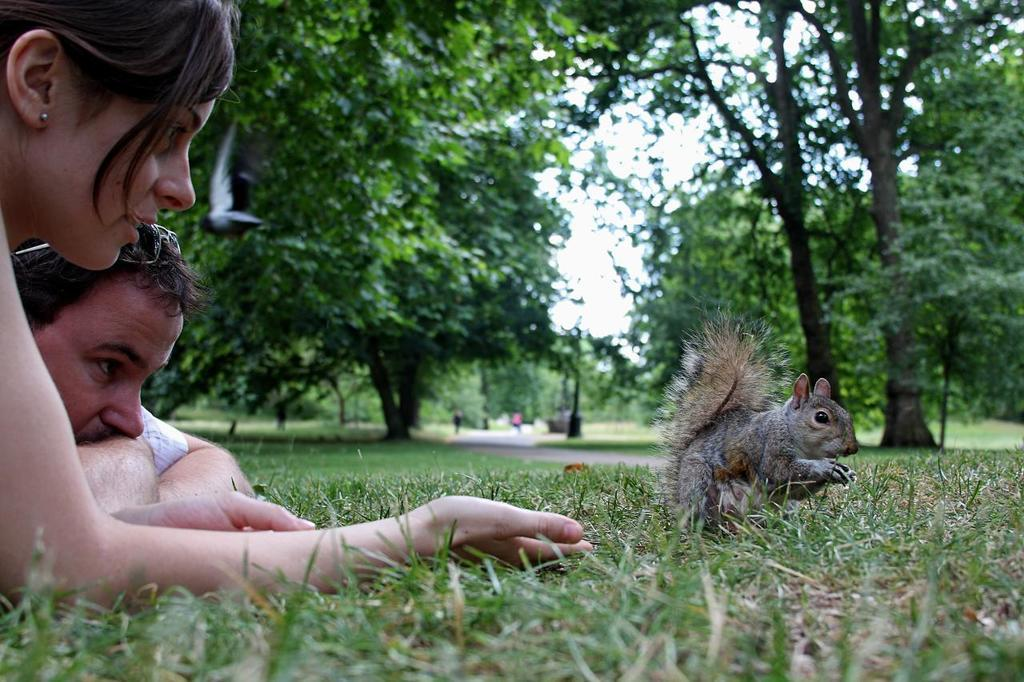What are the two people doing on the left side of the image? There is a man and a lady lying on the grass on the left side of the image. What animal can be seen in the center of the image? There is a squirrel in the center of the image. What type of vegetation is visible in the background of the image? There are trees in the background of the image. What part of the natural environment is visible in the image? The sky is visible in the background of the image. What type of iron is being used by the man in the image? There is no iron present in the image; the man and the lady are lying on the grass. 